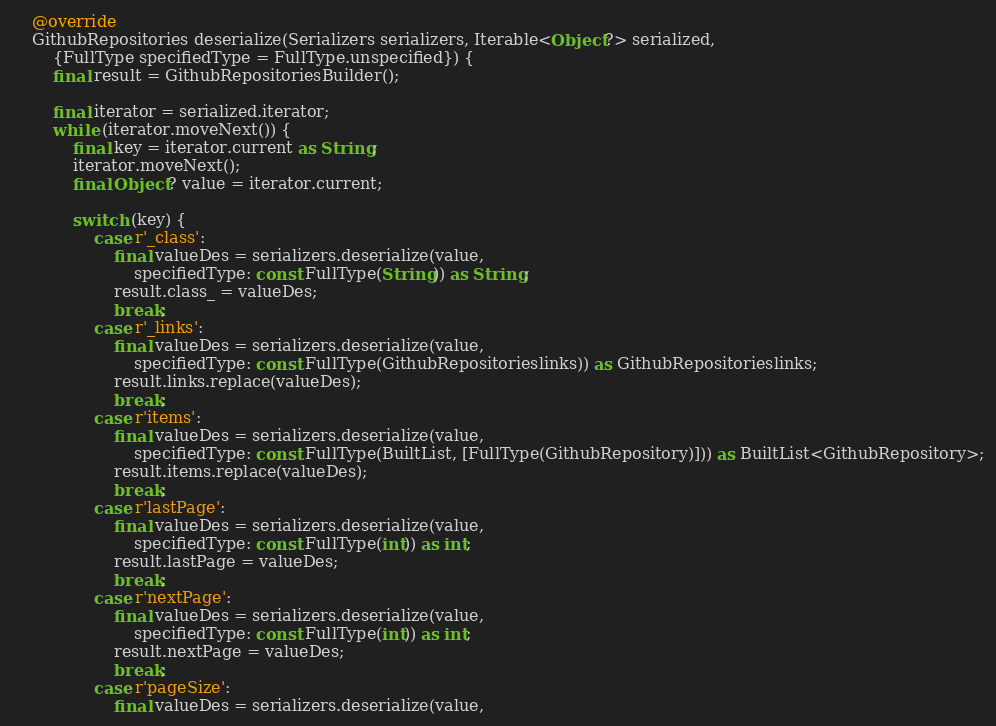<code> <loc_0><loc_0><loc_500><loc_500><_Dart_>
    @override
    GithubRepositories deserialize(Serializers serializers, Iterable<Object?> serialized,
        {FullType specifiedType = FullType.unspecified}) {
        final result = GithubRepositoriesBuilder();

        final iterator = serialized.iterator;
        while (iterator.moveNext()) {
            final key = iterator.current as String;
            iterator.moveNext();
            final Object? value = iterator.current;
            
            switch (key) {
                case r'_class':
                    final valueDes = serializers.deserialize(value,
                        specifiedType: const FullType(String)) as String;
                    result.class_ = valueDes;
                    break;
                case r'_links':
                    final valueDes = serializers.deserialize(value,
                        specifiedType: const FullType(GithubRepositorieslinks)) as GithubRepositorieslinks;
                    result.links.replace(valueDes);
                    break;
                case r'items':
                    final valueDes = serializers.deserialize(value,
                        specifiedType: const FullType(BuiltList, [FullType(GithubRepository)])) as BuiltList<GithubRepository>;
                    result.items.replace(valueDes);
                    break;
                case r'lastPage':
                    final valueDes = serializers.deserialize(value,
                        specifiedType: const FullType(int)) as int;
                    result.lastPage = valueDes;
                    break;
                case r'nextPage':
                    final valueDes = serializers.deserialize(value,
                        specifiedType: const FullType(int)) as int;
                    result.nextPage = valueDes;
                    break;
                case r'pageSize':
                    final valueDes = serializers.deserialize(value,</code> 